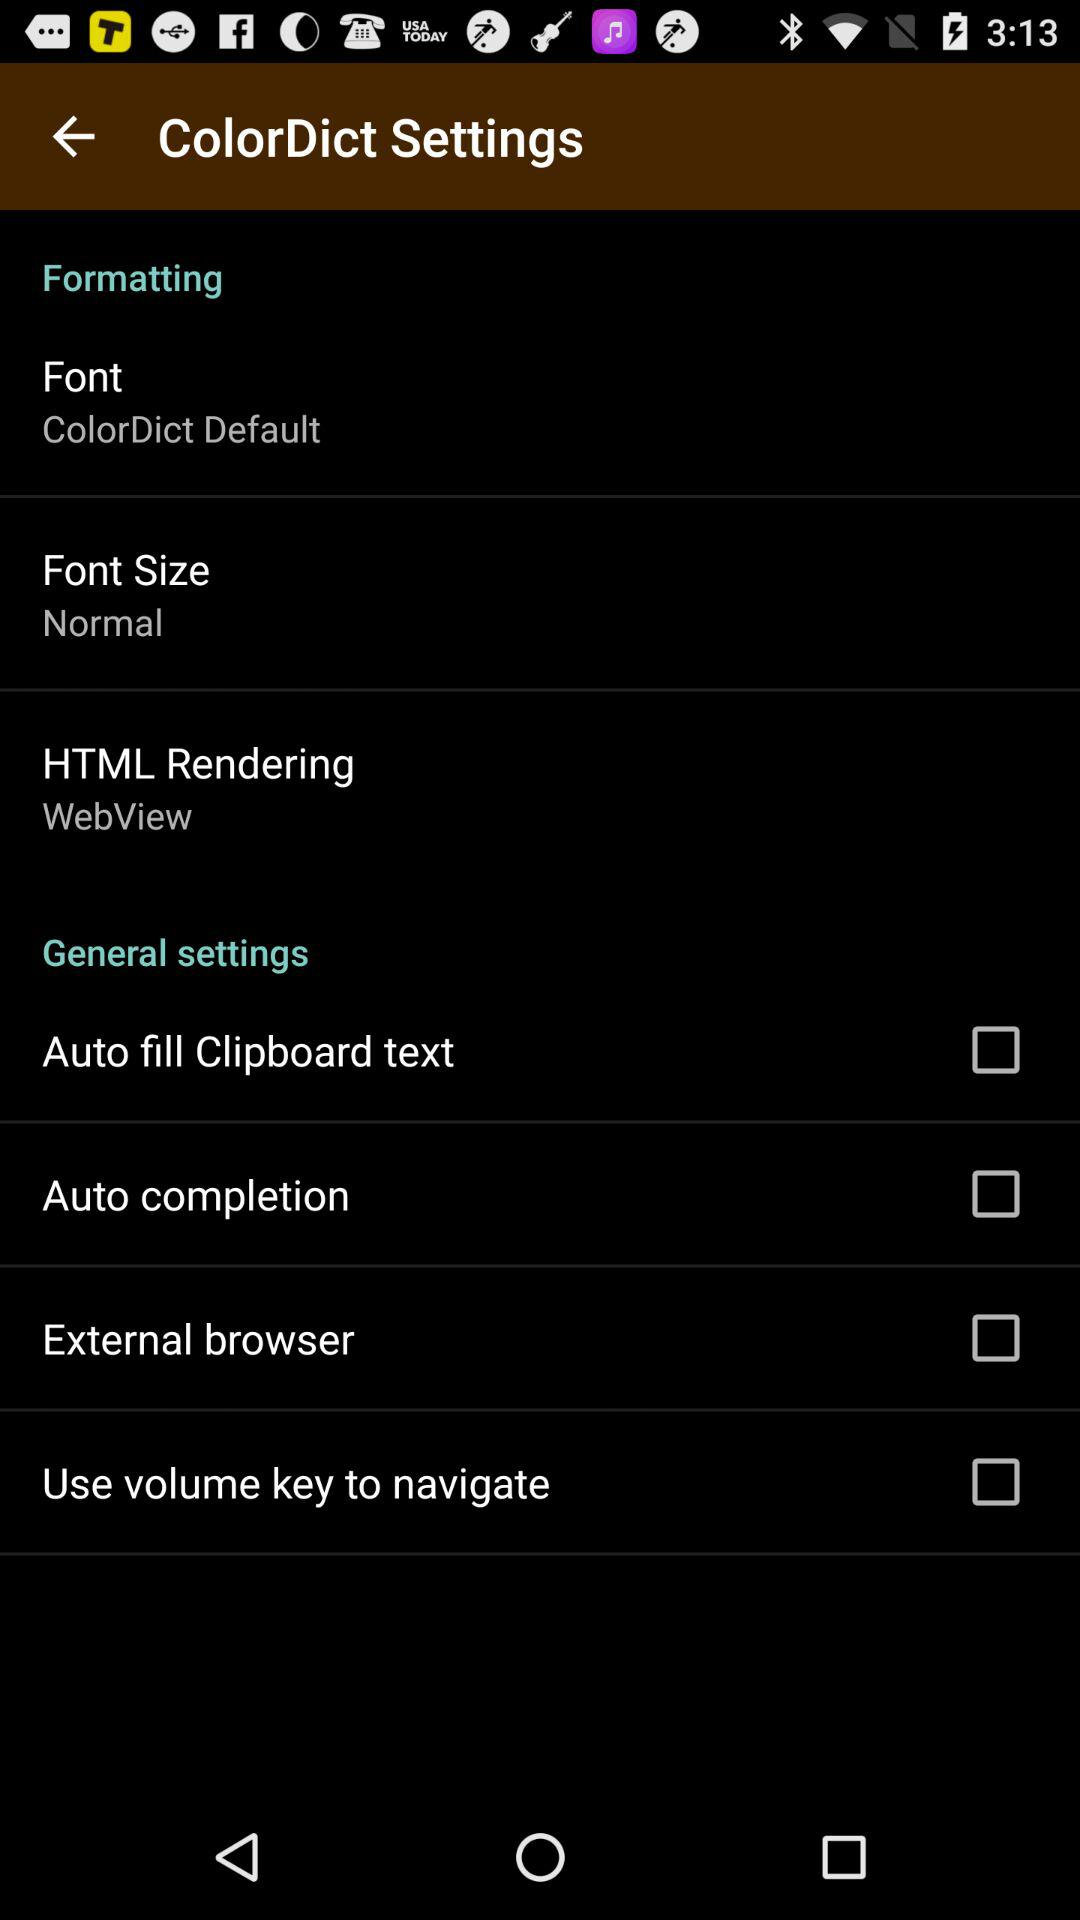What is the font size? The font size is normal. 